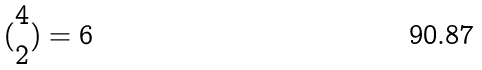Convert formula to latex. <formula><loc_0><loc_0><loc_500><loc_500>( \begin{matrix} 4 \\ 2 \end{matrix} ) = 6</formula> 